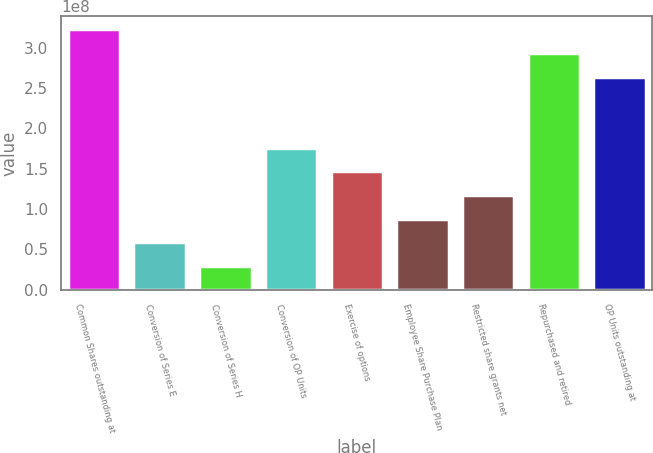Convert chart. <chart><loc_0><loc_0><loc_500><loc_500><bar_chart><fcel>Common Shares outstanding at<fcel>Conversion of Series E<fcel>Conversion of Series H<fcel>Conversion of OP Units<fcel>Exercise of options<fcel>Employee Share Purchase Plan<fcel>Restricted share grants net<fcel>Repurchased and retired<fcel>OP Units outstanding at<nl><fcel>3.22907e+08<fcel>5.87103e+07<fcel>2.93552e+07<fcel>1.76131e+08<fcel>1.46776e+08<fcel>8.80655e+07<fcel>1.17421e+08<fcel>2.93552e+08<fcel>2.64196e+08<nl></chart> 